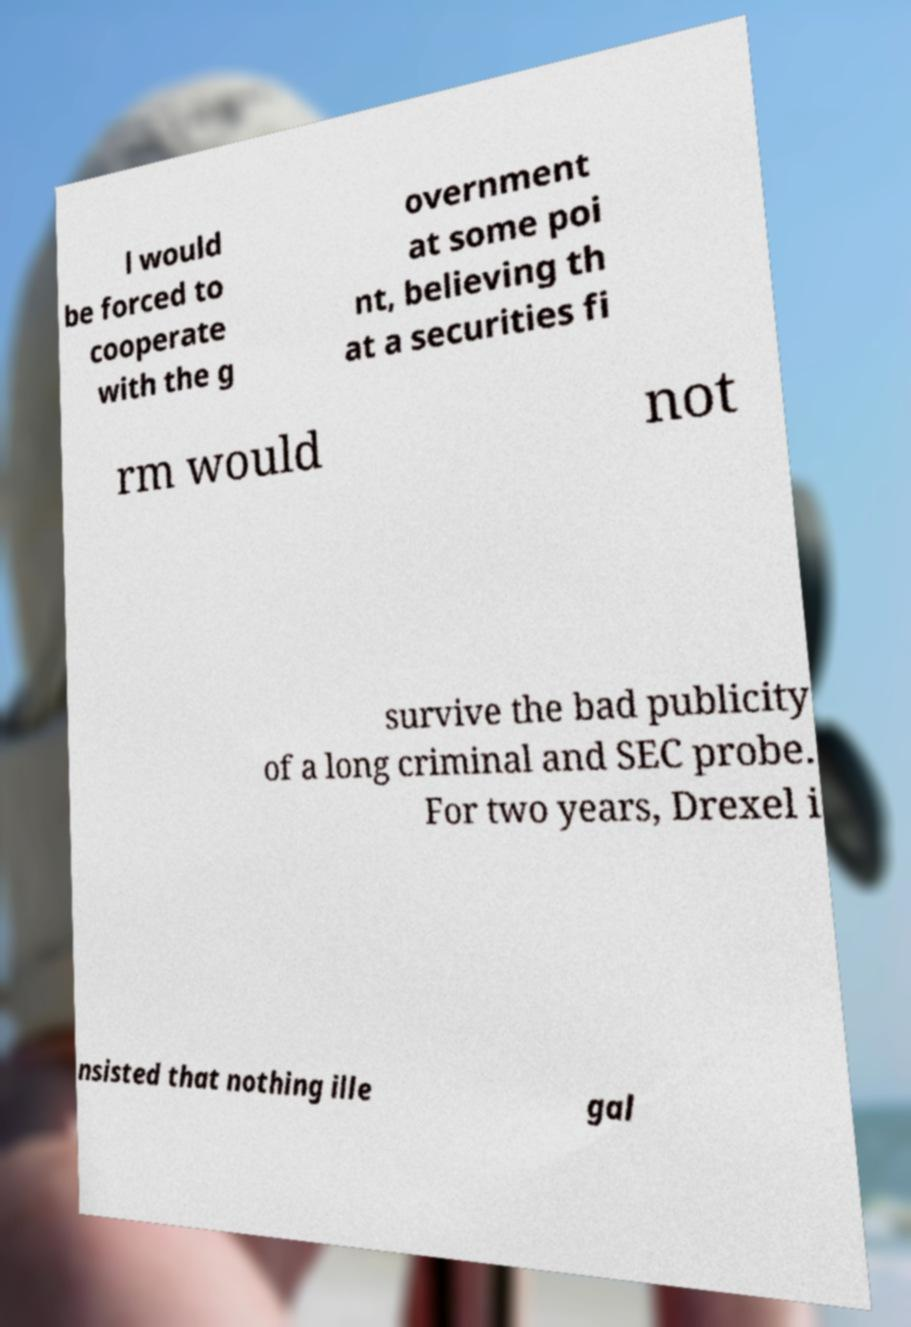What messages or text are displayed in this image? I need them in a readable, typed format. l would be forced to cooperate with the g overnment at some poi nt, believing th at a securities fi rm would not survive the bad publicity of a long criminal and SEC probe. For two years, Drexel i nsisted that nothing ille gal 